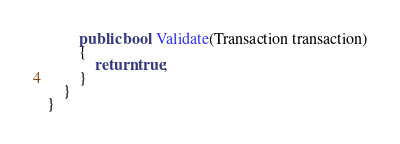Convert code to text. <code><loc_0><loc_0><loc_500><loc_500><_C#_>        public bool Validate(Transaction transaction)
        {
            return true;
        }
    }
}</code> 